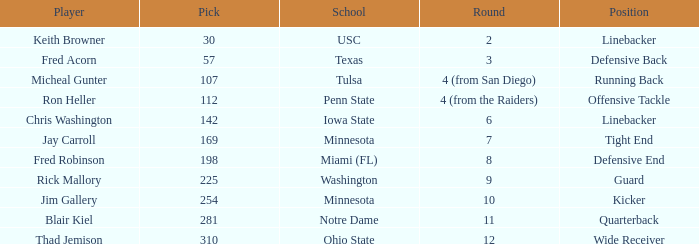What is the pick number of Penn State? 112.0. 